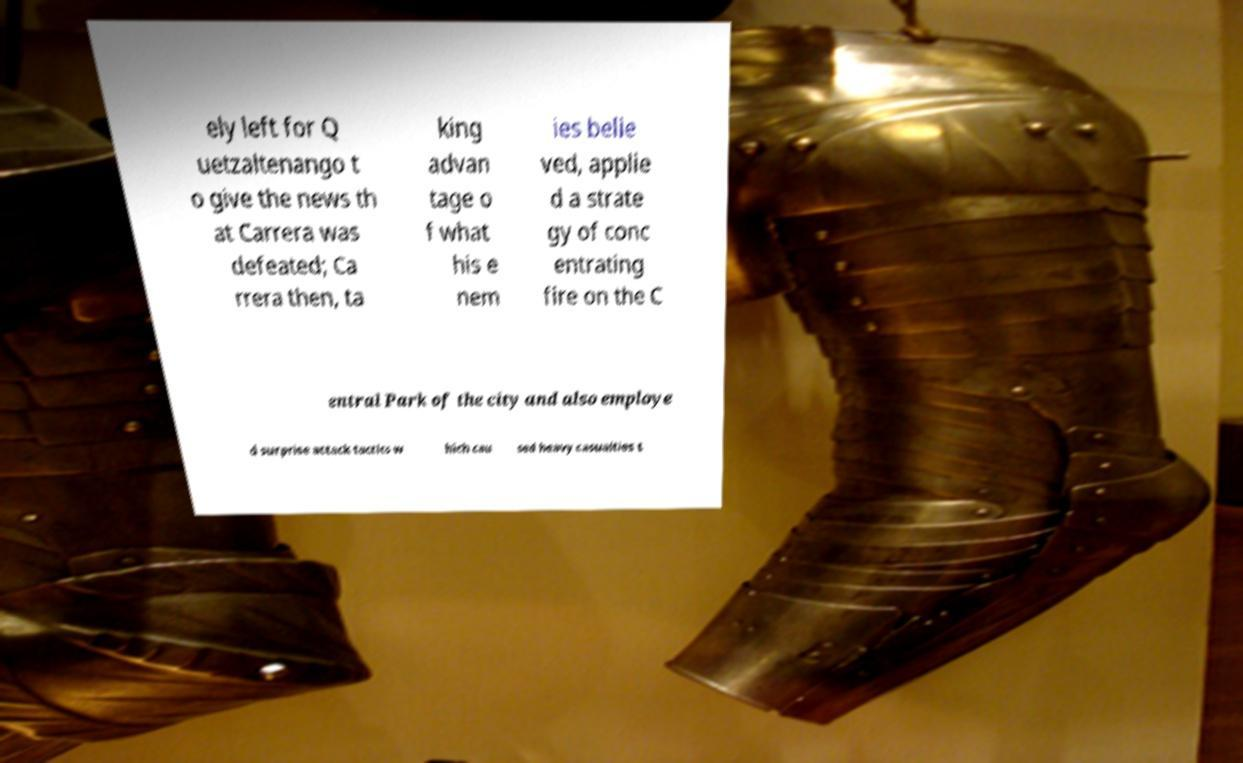Could you assist in decoding the text presented in this image and type it out clearly? ely left for Q uetzaltenango t o give the news th at Carrera was defeated; Ca rrera then, ta king advan tage o f what his e nem ies belie ved, applie d a strate gy of conc entrating fire on the C entral Park of the city and also employe d surprise attack tactics w hich cau sed heavy casualties t 